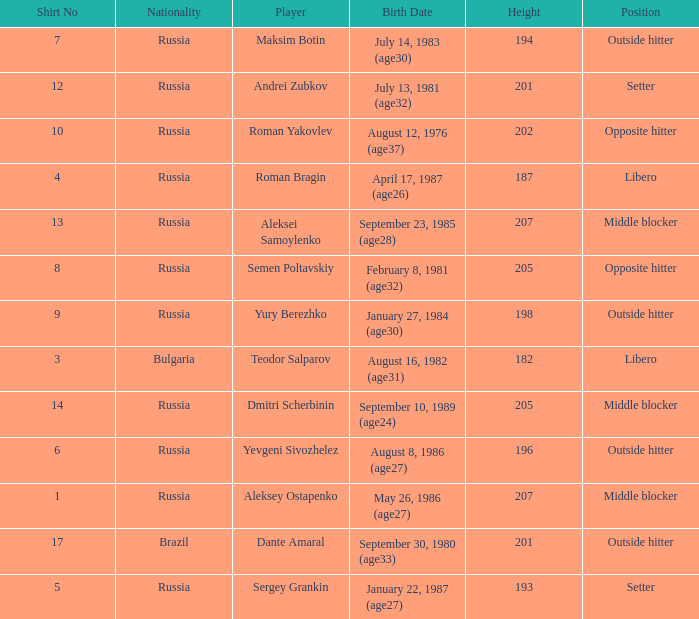What is Roman Bragin's position?  Libero. 